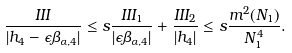<formula> <loc_0><loc_0><loc_500><loc_500>\frac { I I I } { | h _ { 4 } - \epsilon \beta _ { \alpha , 4 } | } \leq s \frac { I I I _ { 1 } } { | \epsilon \beta _ { \alpha , 4 } | } + \frac { I I I _ { 2 } } { | h _ { 4 } | } \leq s \frac { m ^ { 2 } ( N _ { 1 } ) } { N _ { 1 } ^ { 4 } } .</formula> 